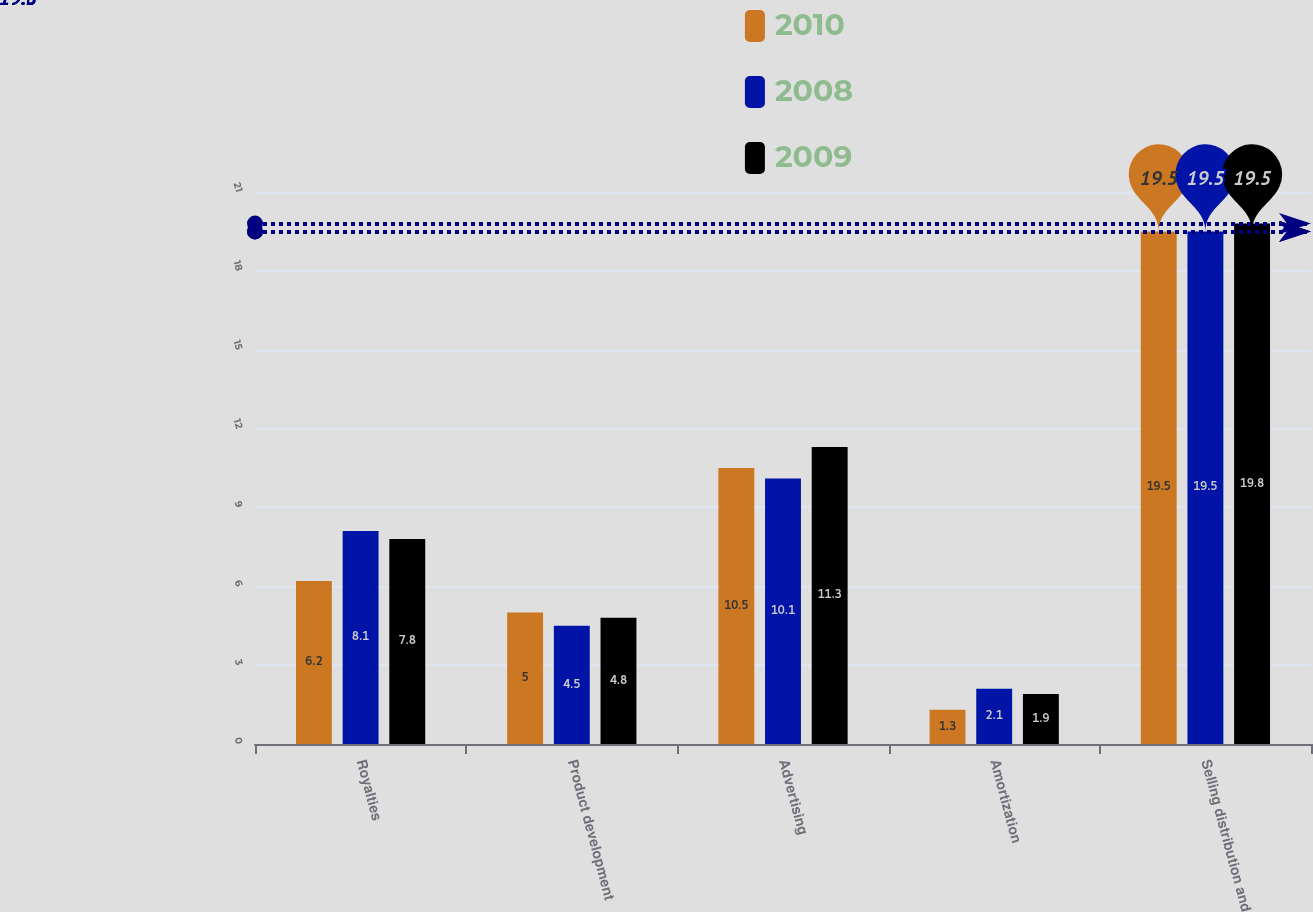<chart> <loc_0><loc_0><loc_500><loc_500><stacked_bar_chart><ecel><fcel>Royalties<fcel>Product development<fcel>Advertising<fcel>Amortization<fcel>Selling distribution and<nl><fcel>2010<fcel>6.2<fcel>5<fcel>10.5<fcel>1.3<fcel>19.5<nl><fcel>2008<fcel>8.1<fcel>4.5<fcel>10.1<fcel>2.1<fcel>19.5<nl><fcel>2009<fcel>7.8<fcel>4.8<fcel>11.3<fcel>1.9<fcel>19.8<nl></chart> 